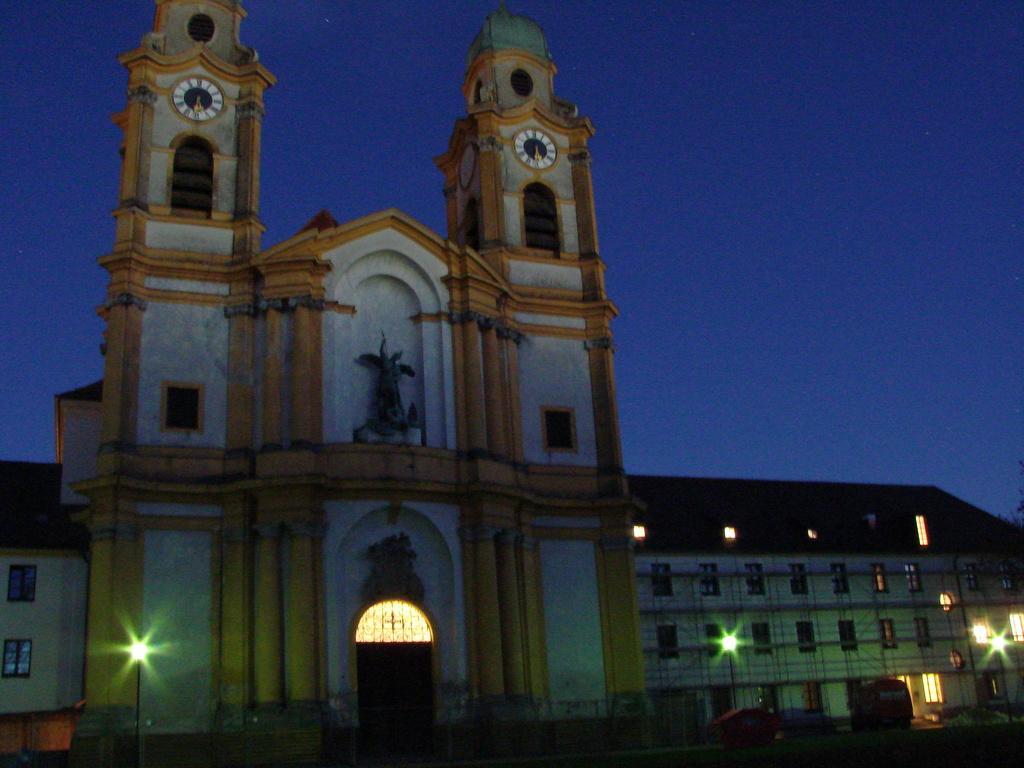Can you describe this image briefly? In this image, I can see the buildings with the windows and the lights. This looks like a sculpture. I can see the wall clocks, which are attached to the building walls. At the top of the image, I can see the sky. At the bottom of the image, these look like the vehicles. 